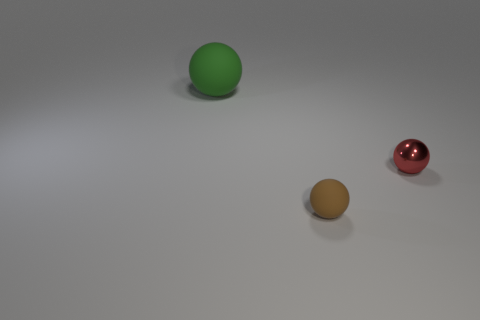How many other things are there of the same material as the brown ball?
Your response must be concise. 1. What number of objects are small objects behind the brown rubber sphere or matte balls that are behind the red shiny object?
Ensure brevity in your answer.  2. There is a matte thing that is in front of the large thing; is its shape the same as the matte thing that is left of the tiny rubber thing?
Offer a terse response. Yes. What number of metallic objects are large green objects or small red spheres?
Give a very brief answer. 1. Does the thing behind the red thing have the same material as the thing to the right of the brown thing?
Provide a short and direct response. No. What is the color of the sphere that is the same material as the tiny brown object?
Provide a short and direct response. Green. Are there more things that are behind the tiny metal thing than red shiny things on the left side of the big green object?
Give a very brief answer. Yes. Are any tiny brown spheres visible?
Your response must be concise. Yes. How many things are large purple metallic blocks or small rubber balls?
Provide a succinct answer. 1. Are there any small spheres that have the same color as the large matte object?
Offer a terse response. No. 